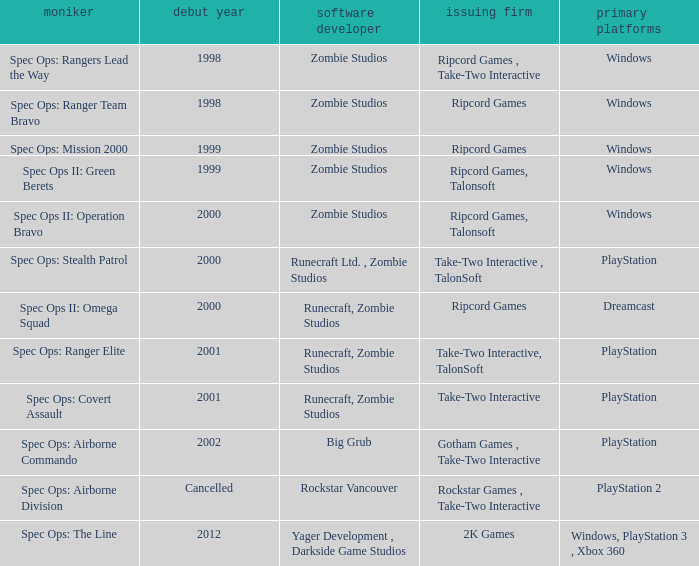Which publisher is responsible for spec ops: stealth patrol? Take-Two Interactive , TalonSoft. 